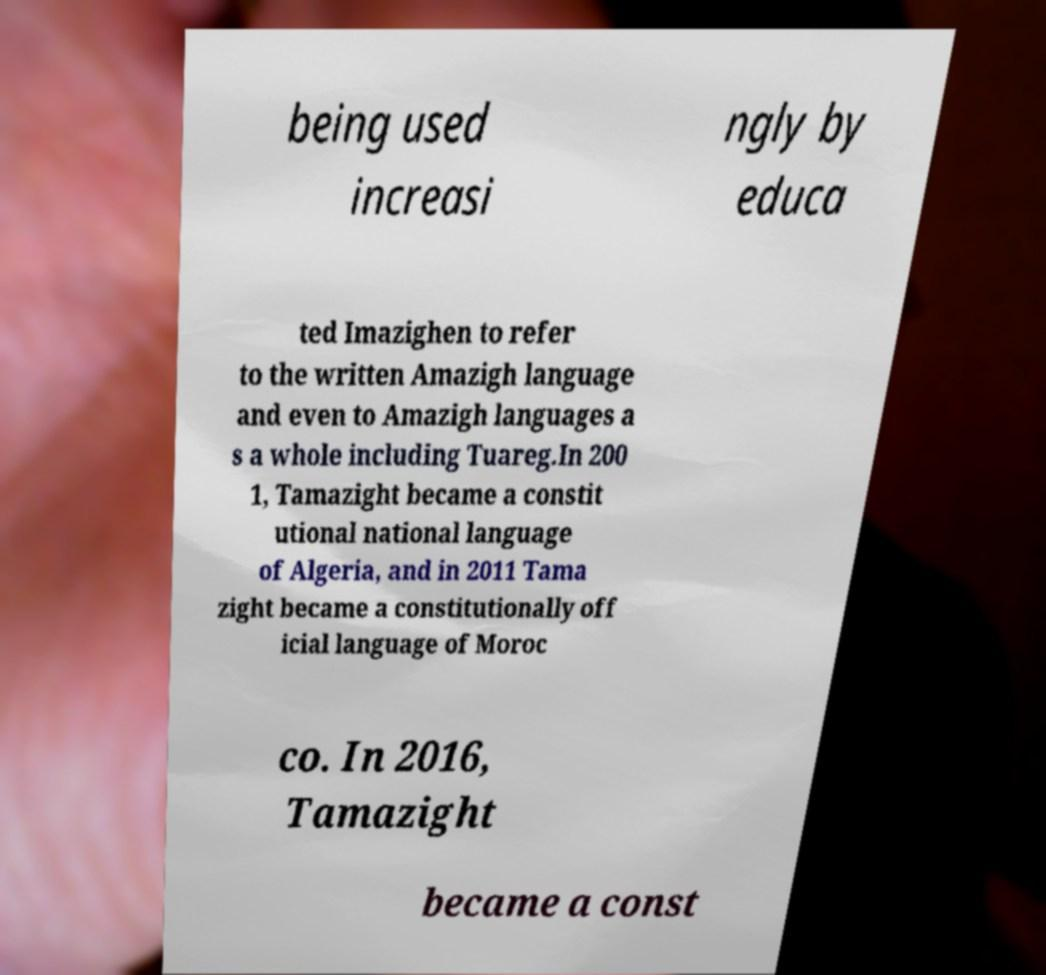For documentation purposes, I need the text within this image transcribed. Could you provide that? being used increasi ngly by educa ted Imazighen to refer to the written Amazigh language and even to Amazigh languages a s a whole including Tuareg.In 200 1, Tamazight became a constit utional national language of Algeria, and in 2011 Tama zight became a constitutionally off icial language of Moroc co. In 2016, Tamazight became a const 